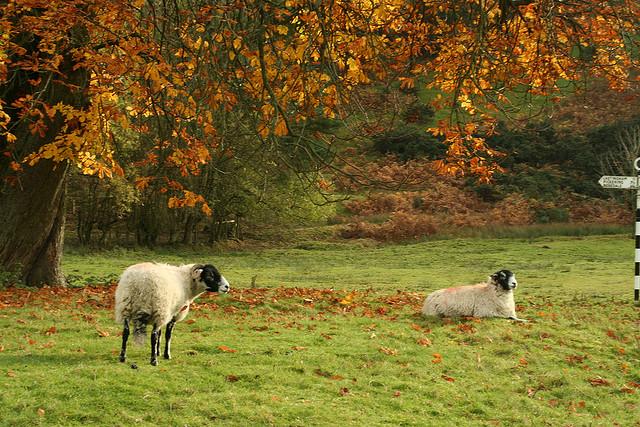Are these animals thinking about nuclear war?
Give a very brief answer. No. Are the animals lying down?
Be succinct. No. What time of year is this?
Be succinct. Fall. 